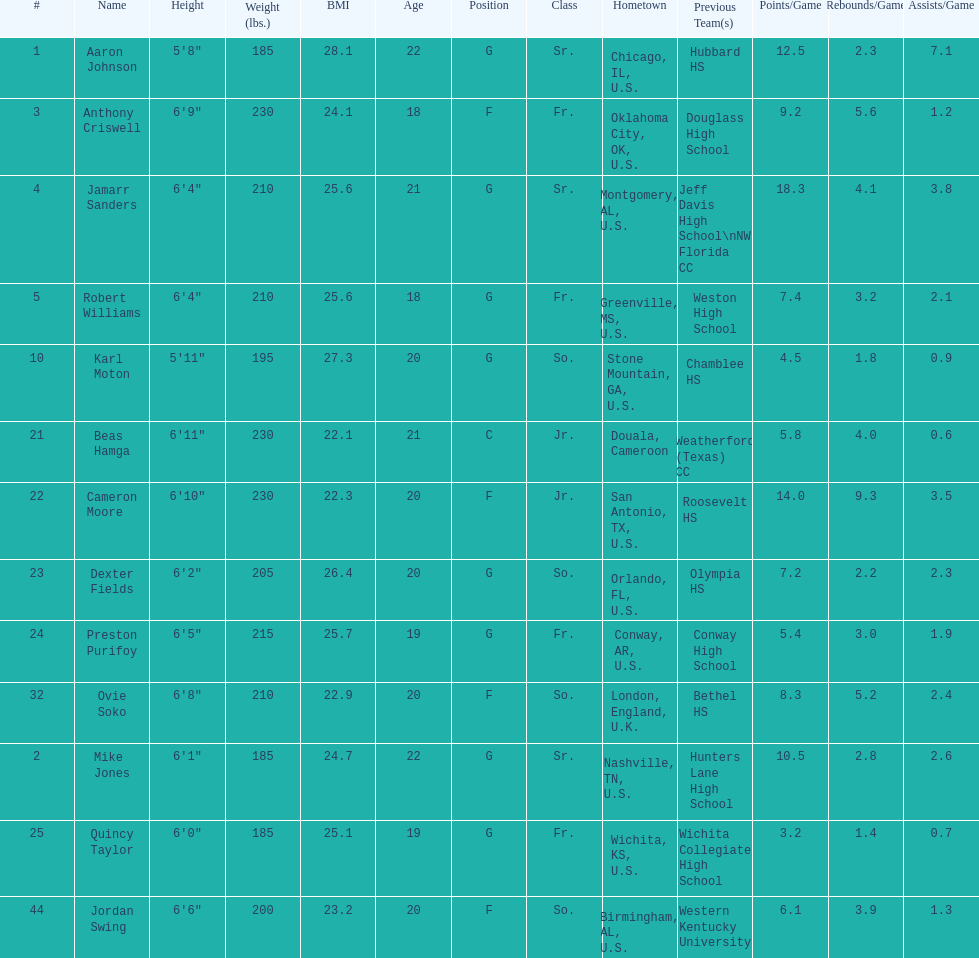Who weighs more, dexter fields or ovie soko? Ovie Soko. 